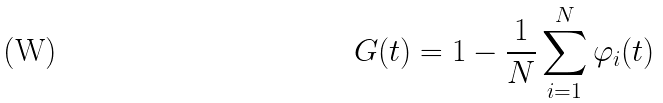<formula> <loc_0><loc_0><loc_500><loc_500>G ( t ) = 1 - \frac { 1 } { N } \sum _ { i = 1 } ^ { N } \varphi _ { i } ( t )</formula> 